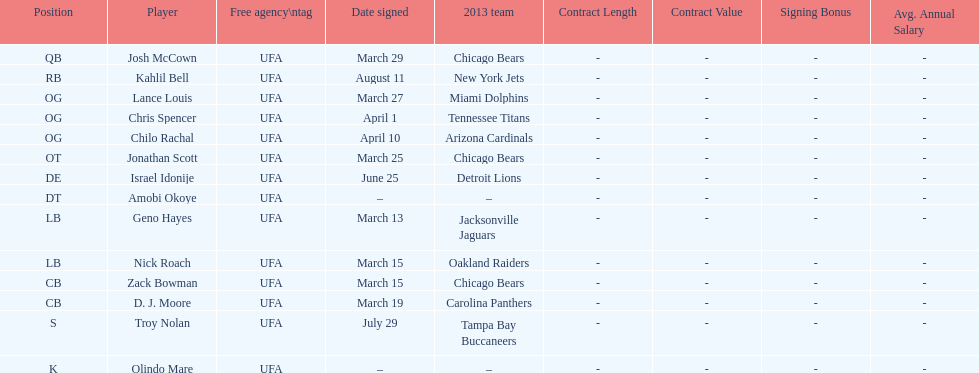Last name is also a first name beginning with "n" Troy Nolan. 